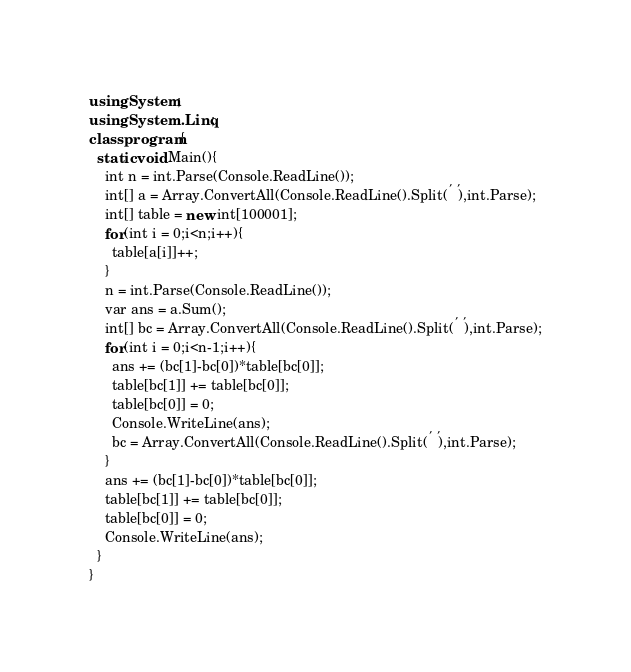Convert code to text. <code><loc_0><loc_0><loc_500><loc_500><_C#_>using System;
using System.Linq;
class program{
  static void Main(){
    int n = int.Parse(Console.ReadLine());
    int[] a = Array.ConvertAll(Console.ReadLine().Split(' '),int.Parse);
    int[] table = new int[100001];
    for(int i = 0;i<n;i++){
      table[a[i]]++;
    }
    n = int.Parse(Console.ReadLine());
    var ans = a.Sum();
    int[] bc = Array.ConvertAll(Console.ReadLine().Split(' '),int.Parse);
    for(int i = 0;i<n-1;i++){
      ans += (bc[1]-bc[0])*table[bc[0]];
      table[bc[1]] += table[bc[0]];
      table[bc[0]] = 0;
      Console.WriteLine(ans);
      bc = Array.ConvertAll(Console.ReadLine().Split(' '),int.Parse);
    }
    ans += (bc[1]-bc[0])*table[bc[0]];
    table[bc[1]] += table[bc[0]];
    table[bc[0]] = 0;
    Console.WriteLine(ans);
  }
}</code> 